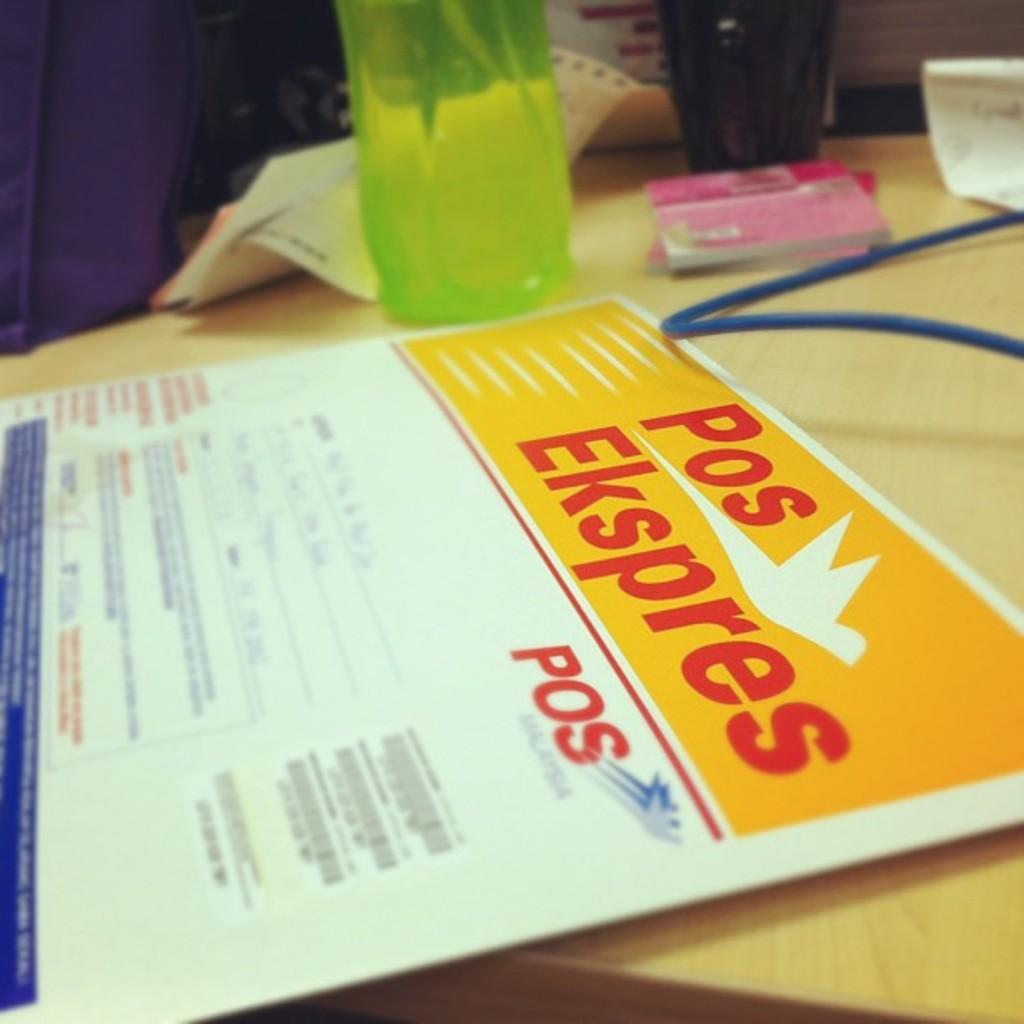What type of person can be seen in the image? There is a courier in the image. What is the courier holding in the image? The courier is holding a water bottle in the image. What other objects are on the table in the image? There is a cup, books, and a paper on the table in the image. Where is the flock of birds located in the image? There is no flock of birds present in the image. What type of board can be seen near the seashore in the image? There is no board or seashore present in the image. 